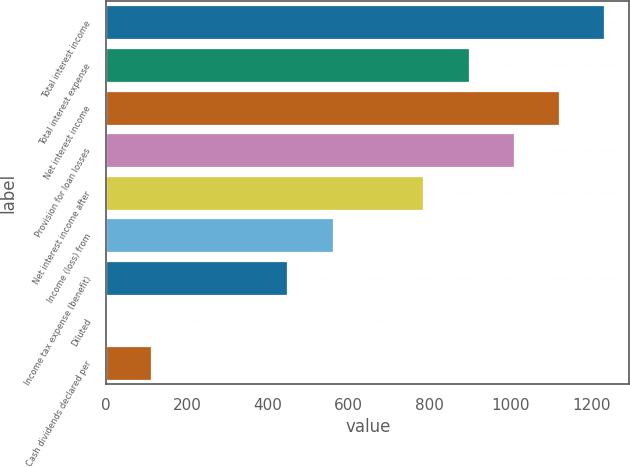Convert chart. <chart><loc_0><loc_0><loc_500><loc_500><bar_chart><fcel>Total interest income<fcel>Total interest expense<fcel>Net interest income<fcel>Provision for loan losses<fcel>Net interest income after<fcel>Income (loss) from<fcel>Income tax expense (benefit)<fcel>Diluted<fcel>Cash dividends declared per<nl><fcel>1232.01<fcel>896.01<fcel>1120.01<fcel>1008.01<fcel>784.01<fcel>560.01<fcel>448.01<fcel>0.01<fcel>112.01<nl></chart> 